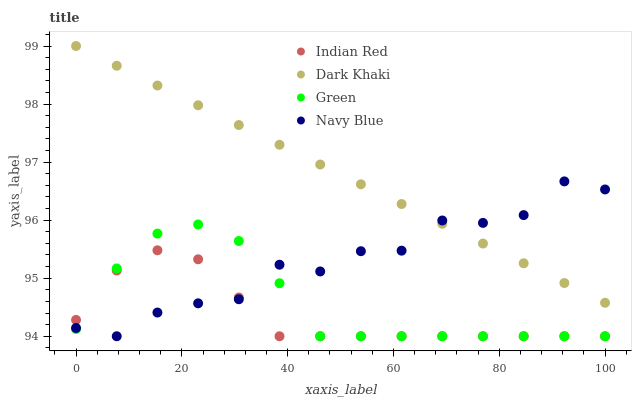Does Indian Red have the minimum area under the curve?
Answer yes or no. Yes. Does Dark Khaki have the maximum area under the curve?
Answer yes or no. Yes. Does Navy Blue have the minimum area under the curve?
Answer yes or no. No. Does Navy Blue have the maximum area under the curve?
Answer yes or no. No. Is Dark Khaki the smoothest?
Answer yes or no. Yes. Is Navy Blue the roughest?
Answer yes or no. Yes. Is Green the smoothest?
Answer yes or no. No. Is Green the roughest?
Answer yes or no. No. Does Navy Blue have the lowest value?
Answer yes or no. Yes. Does Dark Khaki have the highest value?
Answer yes or no. Yes. Does Navy Blue have the highest value?
Answer yes or no. No. Is Indian Red less than Dark Khaki?
Answer yes or no. Yes. Is Dark Khaki greater than Indian Red?
Answer yes or no. Yes. Does Green intersect Navy Blue?
Answer yes or no. Yes. Is Green less than Navy Blue?
Answer yes or no. No. Is Green greater than Navy Blue?
Answer yes or no. No. Does Indian Red intersect Dark Khaki?
Answer yes or no. No. 